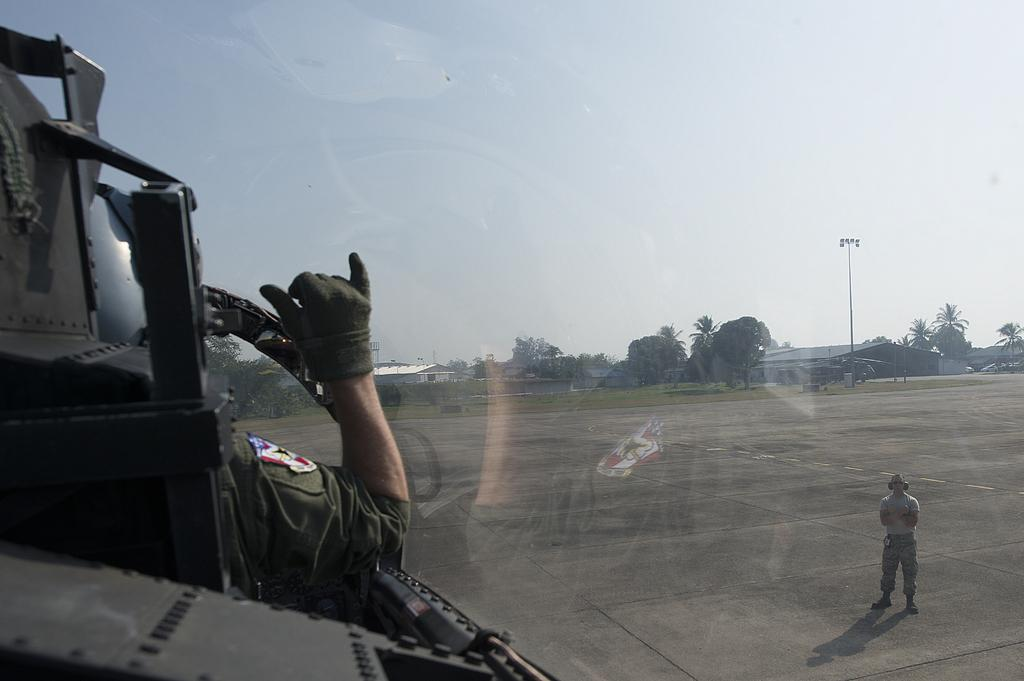What is happening on the right side of the image? There is a person standing on the runway on the right side of the image. What is happening on the left side of the image? There is a person on the left side of the image. What can be seen in the background of the image? There are trees and the sky visible in the background of the image. What type of tomatoes are being grown by the person on the left side of the image? There are no tomatoes or gardening activities present in the image. What type of plants can be seen growing on the runway? There are no plants growing on the runway in the image. 